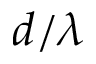<formula> <loc_0><loc_0><loc_500><loc_500>d / \lambda</formula> 